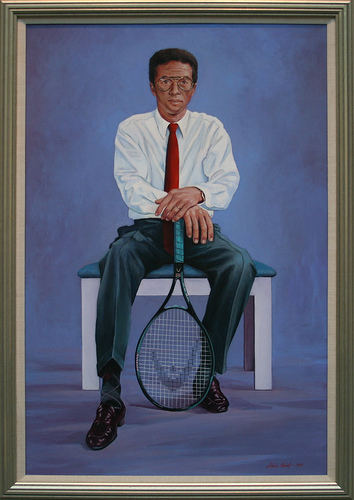What might the man be thinking as he sits there with the tennis racket? The man might be reflecting on his achievements in tennis, perhaps remembering key moments of his career or important matches. His calm yet determined expression suggests a sense of satisfaction and pride in his accomplishments. 